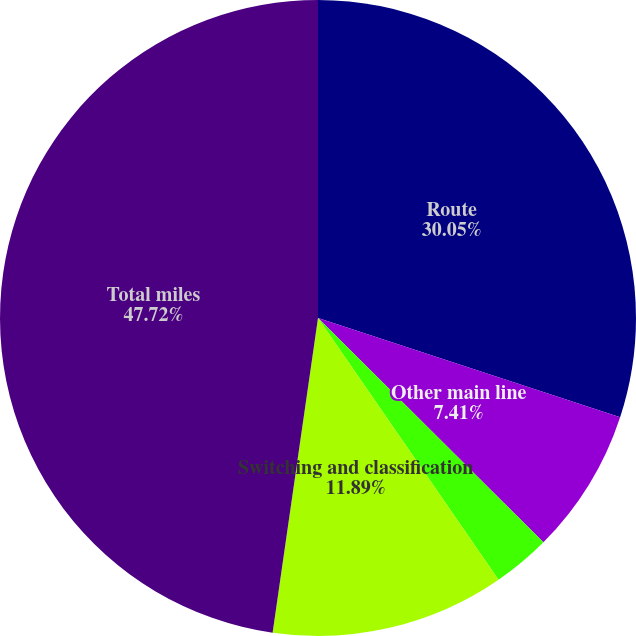Convert chart to OTSL. <chart><loc_0><loc_0><loc_500><loc_500><pie_chart><fcel>Route<fcel>Other main line<fcel>Passing lines and turnouts<fcel>Switching and classification<fcel>Total miles<nl><fcel>30.05%<fcel>7.41%<fcel>2.93%<fcel>11.89%<fcel>47.72%<nl></chart> 